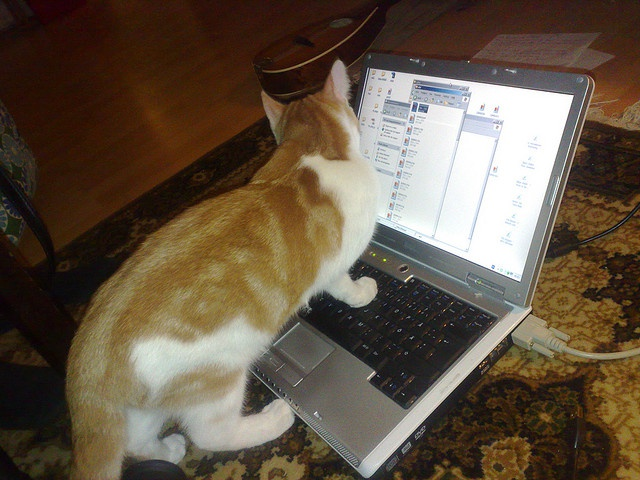Describe the objects in this image and their specific colors. I can see laptop in black, white, gray, and darkgray tones and cat in black, olive, and darkgray tones in this image. 